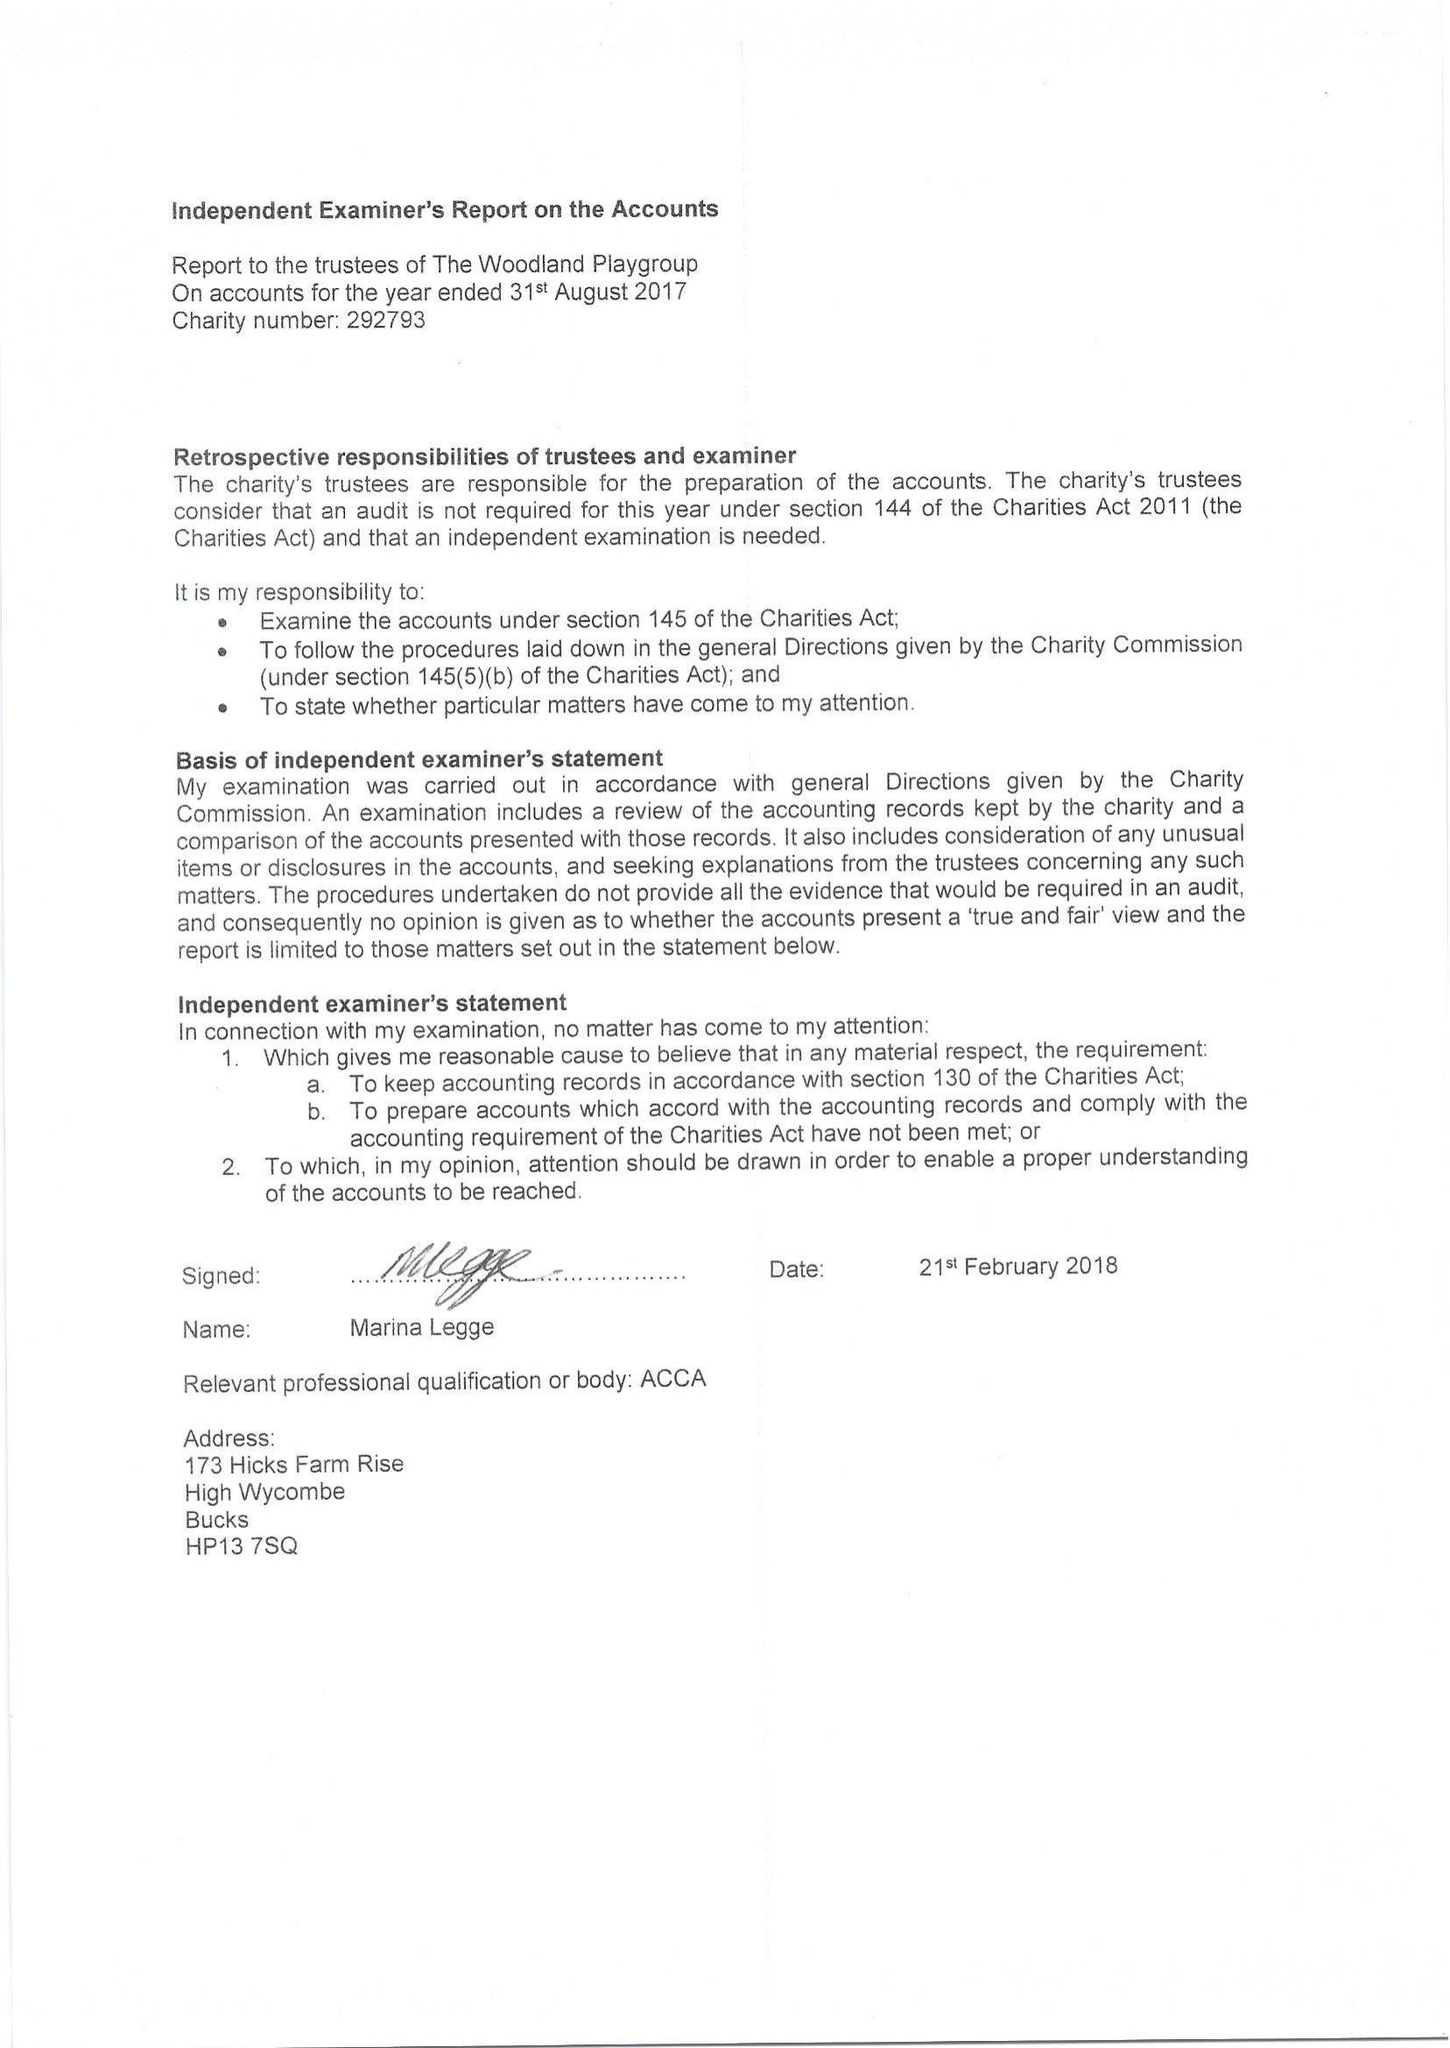What is the value for the report_date?
Answer the question using a single word or phrase. 2018-08-31 